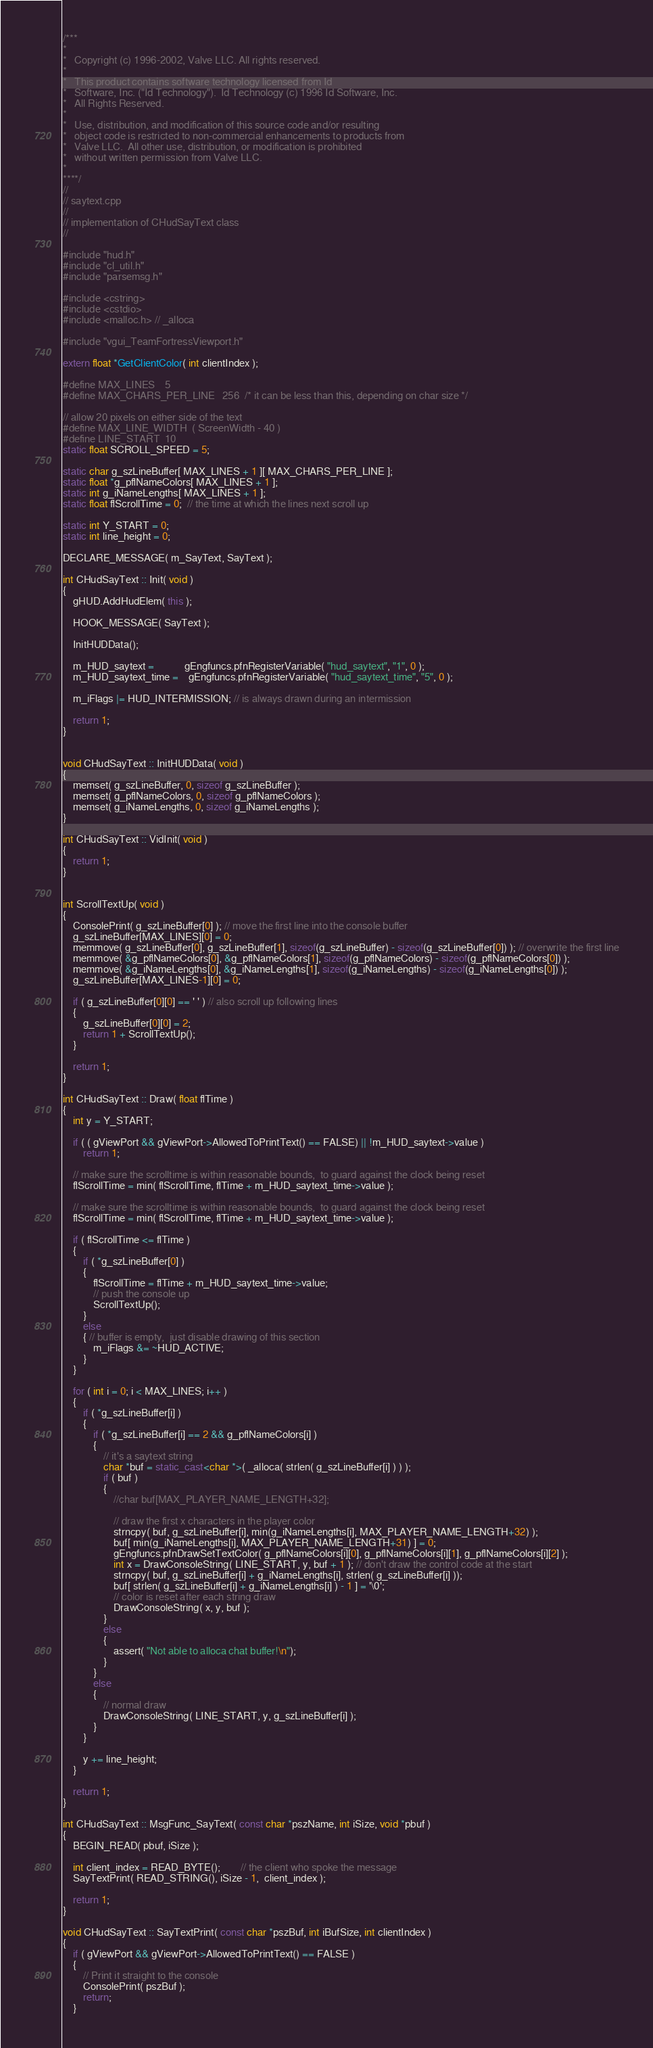Convert code to text. <code><loc_0><loc_0><loc_500><loc_500><_C++_>/***
*
*	Copyright (c) 1996-2002, Valve LLC. All rights reserved.
*	
*	This product contains software technology licensed from Id 
*	Software, Inc. ("Id Technology").  Id Technology (c) 1996 Id Software, Inc. 
*	All Rights Reserved.
*
*   Use, distribution, and modification of this source code and/or resulting
*   object code is restricted to non-commercial enhancements to products from
*   Valve LLC.  All other use, distribution, or modification is prohibited
*   without written permission from Valve LLC.
*
****/
//
// saytext.cpp
//
// implementation of CHudSayText class
//

#include "hud.h"
#include "cl_util.h"
#include "parsemsg.h"

#include <cstring>
#include <cstdio>
#include <malloc.h> // _alloca

#include "vgui_TeamFortressViewport.h"

extern float *GetClientColor( int clientIndex );

#define MAX_LINES	5
#define MAX_CHARS_PER_LINE	256  /* it can be less than this, depending on char size */

// allow 20 pixels on either side of the text
#define MAX_LINE_WIDTH  ( ScreenWidth - 40 )
#define LINE_START  10
static float SCROLL_SPEED = 5;

static char g_szLineBuffer[ MAX_LINES + 1 ][ MAX_CHARS_PER_LINE ];
static float *g_pflNameColors[ MAX_LINES + 1 ];
static int g_iNameLengths[ MAX_LINES + 1 ];
static float flScrollTime = 0;  // the time at which the lines next scroll up

static int Y_START = 0;
static int line_height = 0;

DECLARE_MESSAGE( m_SayText, SayText );

int CHudSayText :: Init( void )
{
	gHUD.AddHudElem( this );

	HOOK_MESSAGE( SayText );

	InitHUDData();

	m_HUD_saytext =			gEngfuncs.pfnRegisterVariable( "hud_saytext", "1", 0 );
	m_HUD_saytext_time =	gEngfuncs.pfnRegisterVariable( "hud_saytext_time", "5", 0 );

	m_iFlags |= HUD_INTERMISSION; // is always drawn during an intermission

	return 1;
}


void CHudSayText :: InitHUDData( void )
{
	memset( g_szLineBuffer, 0, sizeof g_szLineBuffer );
	memset( g_pflNameColors, 0, sizeof g_pflNameColors );
	memset( g_iNameLengths, 0, sizeof g_iNameLengths );
}

int CHudSayText :: VidInit( void )
{
	return 1;
}


int ScrollTextUp( void )
{
	ConsolePrint( g_szLineBuffer[0] ); // move the first line into the console buffer
	g_szLineBuffer[MAX_LINES][0] = 0;
	memmove( g_szLineBuffer[0], g_szLineBuffer[1], sizeof(g_szLineBuffer) - sizeof(g_szLineBuffer[0]) ); // overwrite the first line
	memmove( &g_pflNameColors[0], &g_pflNameColors[1], sizeof(g_pflNameColors) - sizeof(g_pflNameColors[0]) );
	memmove( &g_iNameLengths[0], &g_iNameLengths[1], sizeof(g_iNameLengths) - sizeof(g_iNameLengths[0]) );
	g_szLineBuffer[MAX_LINES-1][0] = 0;

	if ( g_szLineBuffer[0][0] == ' ' ) // also scroll up following lines
	{
		g_szLineBuffer[0][0] = 2;
		return 1 + ScrollTextUp();
	}

	return 1;
}

int CHudSayText :: Draw( float flTime )
{
	int y = Y_START;

	if ( ( gViewPort && gViewPort->AllowedToPrintText() == FALSE) || !m_HUD_saytext->value )
		return 1;

	// make sure the scrolltime is within reasonable bounds,  to guard against the clock being reset
	flScrollTime = min( flScrollTime, flTime + m_HUD_saytext_time->value );

	// make sure the scrolltime is within reasonable bounds,  to guard against the clock being reset
	flScrollTime = min( flScrollTime, flTime + m_HUD_saytext_time->value );

	if ( flScrollTime <= flTime )
	{
		if ( *g_szLineBuffer[0] )
		{
			flScrollTime = flTime + m_HUD_saytext_time->value;
			// push the console up
			ScrollTextUp();
		}
		else
		{ // buffer is empty,  just disable drawing of this section
			m_iFlags &= ~HUD_ACTIVE;
		}
	}

	for ( int i = 0; i < MAX_LINES; i++ )
	{
		if ( *g_szLineBuffer[i] )
		{
			if ( *g_szLineBuffer[i] == 2 && g_pflNameColors[i] )
			{
				// it's a saytext string
				char *buf = static_cast<char *>( _alloca( strlen( g_szLineBuffer[i] ) ) );
				if ( buf )
				{
					//char buf[MAX_PLAYER_NAME_LENGTH+32];

					// draw the first x characters in the player color
					strncpy( buf, g_szLineBuffer[i], min(g_iNameLengths[i], MAX_PLAYER_NAME_LENGTH+32) );
					buf[ min(g_iNameLengths[i], MAX_PLAYER_NAME_LENGTH+31) ] = 0;
					gEngfuncs.pfnDrawSetTextColor( g_pflNameColors[i][0], g_pflNameColors[i][1], g_pflNameColors[i][2] );
					int x = DrawConsoleString( LINE_START, y, buf + 1 ); // don't draw the control code at the start
					strncpy( buf, g_szLineBuffer[i] + g_iNameLengths[i], strlen( g_szLineBuffer[i] ));
					buf[ strlen( g_szLineBuffer[i] + g_iNameLengths[i] ) - 1 ] = '\0';
					// color is reset after each string draw
					DrawConsoleString( x, y, buf ); 
				}
				else
				{
					assert( "Not able to alloca chat buffer!\n");
				}
			}
			else
			{
				// normal draw
				DrawConsoleString( LINE_START, y, g_szLineBuffer[i] );
			}
		}

		y += line_height;
	}

	return 1;
}

int CHudSayText :: MsgFunc_SayText( const char *pszName, int iSize, void *pbuf )
{
	BEGIN_READ( pbuf, iSize );

	int client_index = READ_BYTE();		// the client who spoke the message
	SayTextPrint( READ_STRING(), iSize - 1,  client_index );
	
	return 1;
}

void CHudSayText :: SayTextPrint( const char *pszBuf, int iBufSize, int clientIndex )
{
	if ( gViewPort && gViewPort->AllowedToPrintText() == FALSE )
	{
		// Print it straight to the console
		ConsolePrint( pszBuf );
		return;
	}
</code> 